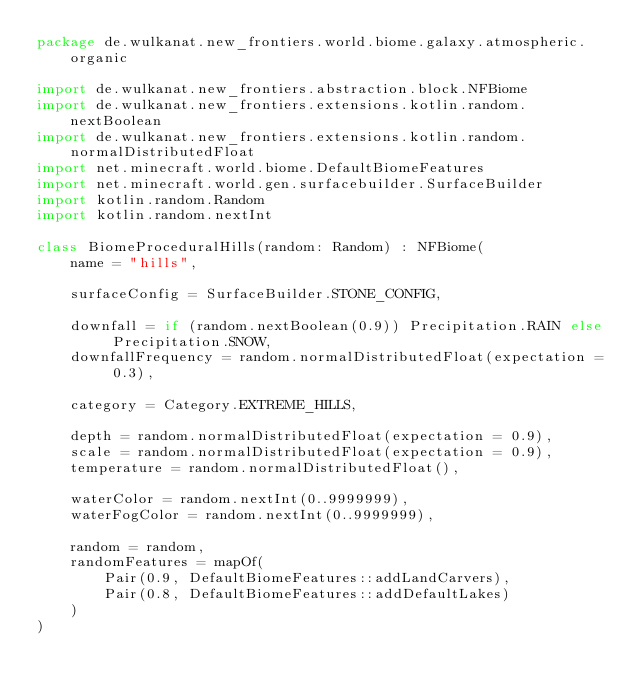<code> <loc_0><loc_0><loc_500><loc_500><_Kotlin_>package de.wulkanat.new_frontiers.world.biome.galaxy.atmospheric.organic

import de.wulkanat.new_frontiers.abstraction.block.NFBiome
import de.wulkanat.new_frontiers.extensions.kotlin.random.nextBoolean
import de.wulkanat.new_frontiers.extensions.kotlin.random.normalDistributedFloat
import net.minecraft.world.biome.DefaultBiomeFeatures
import net.minecraft.world.gen.surfacebuilder.SurfaceBuilder
import kotlin.random.Random
import kotlin.random.nextInt

class BiomeProceduralHills(random: Random) : NFBiome(
    name = "hills",

    surfaceConfig = SurfaceBuilder.STONE_CONFIG,

    downfall = if (random.nextBoolean(0.9)) Precipitation.RAIN else Precipitation.SNOW,
    downfallFrequency = random.normalDistributedFloat(expectation = 0.3),

    category = Category.EXTREME_HILLS,

    depth = random.normalDistributedFloat(expectation = 0.9),
    scale = random.normalDistributedFloat(expectation = 0.9),
    temperature = random.normalDistributedFloat(),

    waterColor = random.nextInt(0..9999999),
    waterFogColor = random.nextInt(0..9999999),

    random = random,
    randomFeatures = mapOf(
        Pair(0.9, DefaultBiomeFeatures::addLandCarvers),
        Pair(0.8, DefaultBiomeFeatures::addDefaultLakes)
    )
)</code> 